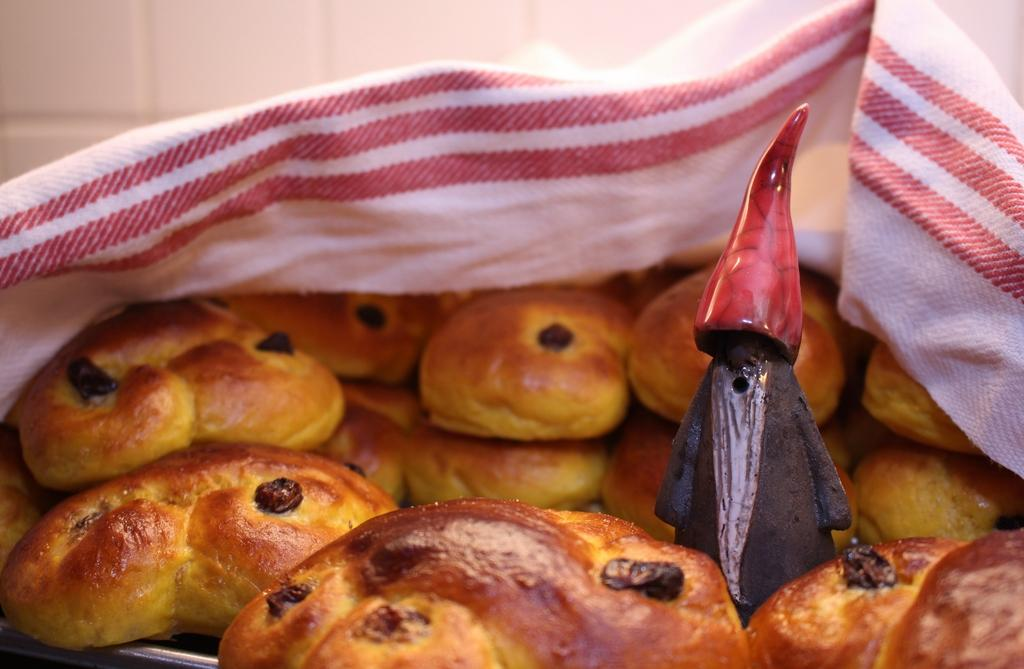What is on the plate in the image? There are bones on a plate in the image. What else can be seen on the plate besides the bones? There is an unidentified object in the middle of the plate. Can you describe the appearance of the unidentified object? The unidentified object is covered by a cloth. What type of fork is used to eat the history depicted in the image? There is no fork or history present in the image; it features bones on a plate with an unidentified object covered by a cloth. What type of cannon is visible in the image? There is no cannon present in the image. 